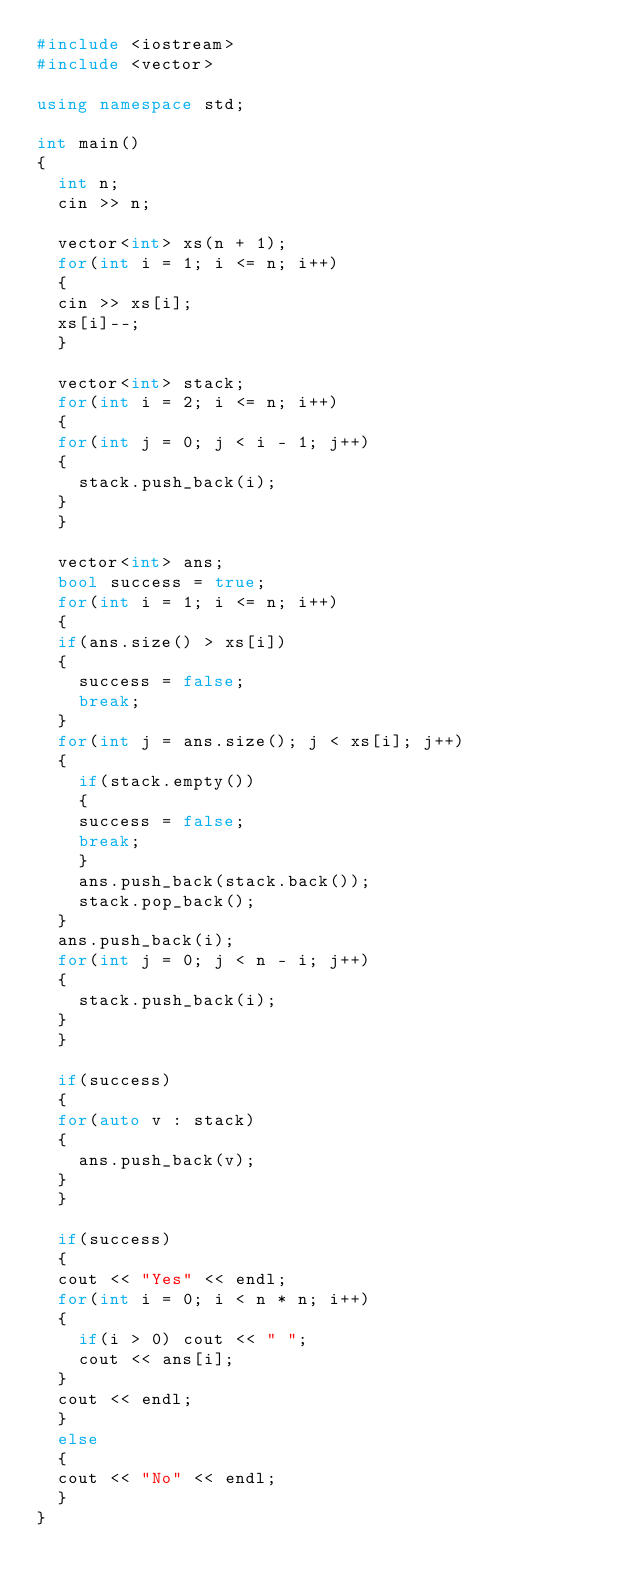<code> <loc_0><loc_0><loc_500><loc_500><_C++_>#include <iostream>
#include <vector>

using namespace std;

int main()
{
  int n;
  cin >> n;
  
  vector<int> xs(n + 1);
  for(int i = 1; i <= n; i++)
  {
	cin >> xs[i];
	xs[i]--;
  }

  vector<int> stack;
  for(int i = 2; i <= n; i++)
  {
	for(int j = 0; j < i - 1; j++)
	{
	  stack.push_back(i);
	}
  }

  vector<int> ans;
  bool success = true;
  for(int i = 1; i <= n; i++)
  {
	if(ans.size() > xs[i])
	{
	  success = false;
	  break;
	}
	for(int j = ans.size(); j < xs[i]; j++)
	{
	  if(stack.empty())
	  {
		success = false;
		break;
	  }
	  ans.push_back(stack.back());
	  stack.pop_back();
	}
	ans.push_back(i);
	for(int j = 0; j < n - i; j++)
	{
	  stack.push_back(i);
	}
  }

  if(success)
  {
	for(auto v : stack)
	{
	  ans.push_back(v);
	}
  }

  if(success)
  {
	cout << "Yes" << endl;
	for(int i = 0; i < n * n; i++)
	{
	  if(i > 0) cout << " ";
	  cout << ans[i];
	}
	cout << endl;
  }
  else
  {
	cout << "No" << endl;
  }  
}
</code> 